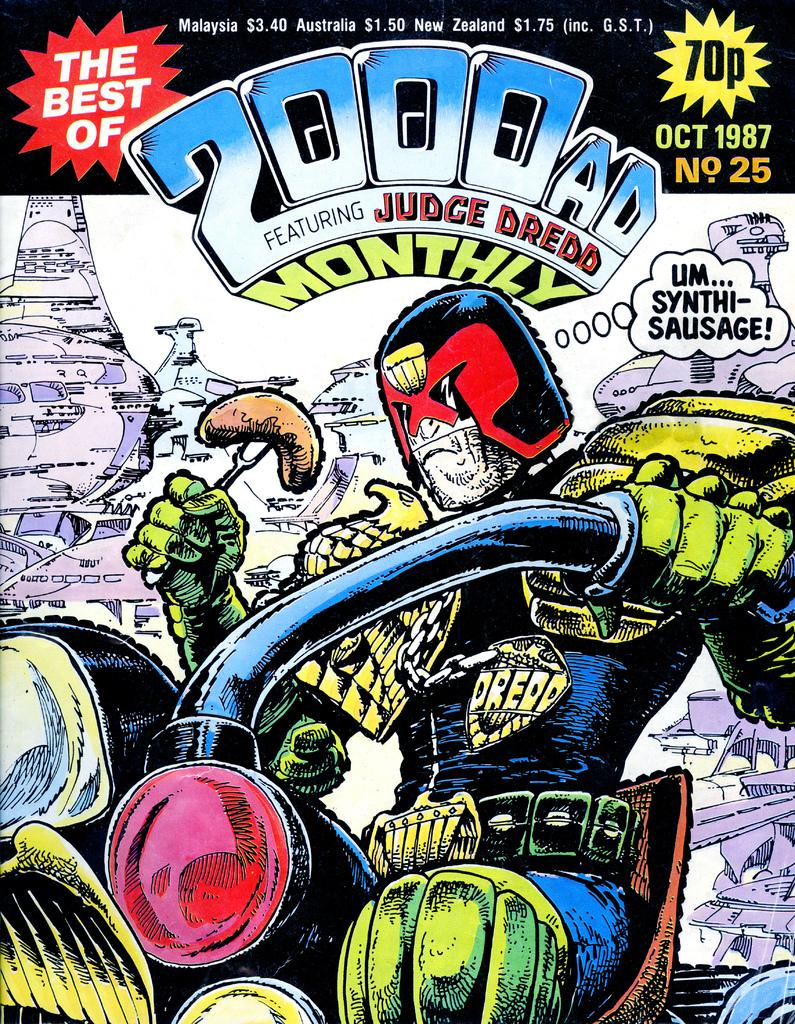What is the main subject of the image? There is a person in the image. What is the person doing in the image? The person is sitting on a bike. What is the person holding in the image? The person is holding something. What can be seen in the background of the image? There are objects in the background of the image. Is there any text present in the image? Yes, there is text in the image. How many nails can be seen in the image? There are no nails present in the image. How many visitors are visible in the image? There is no mention of visitors in the image; it only features a person sitting on a bike. 